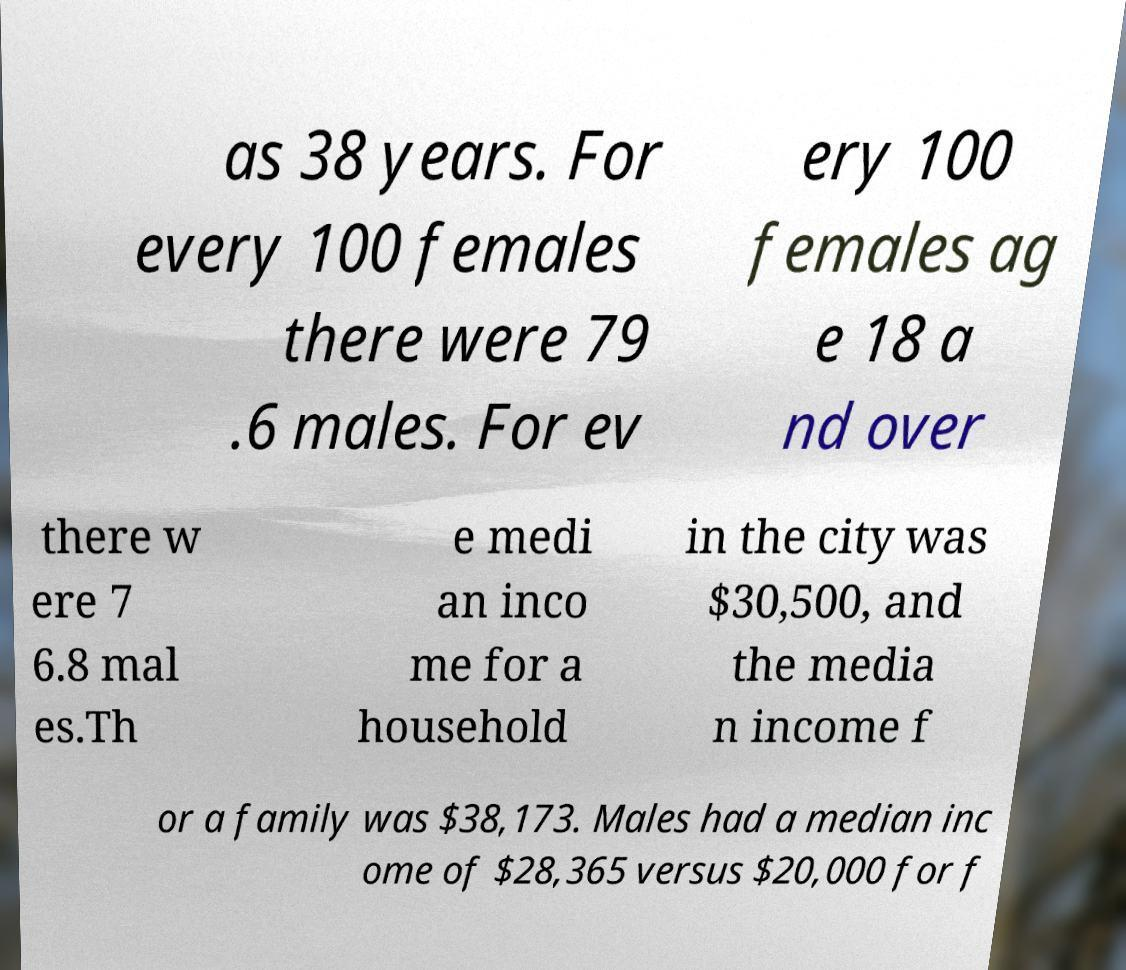Can you accurately transcribe the text from the provided image for me? as 38 years. For every 100 females there were 79 .6 males. For ev ery 100 females ag e 18 a nd over there w ere 7 6.8 mal es.Th e medi an inco me for a household in the city was $30,500, and the media n income f or a family was $38,173. Males had a median inc ome of $28,365 versus $20,000 for f 